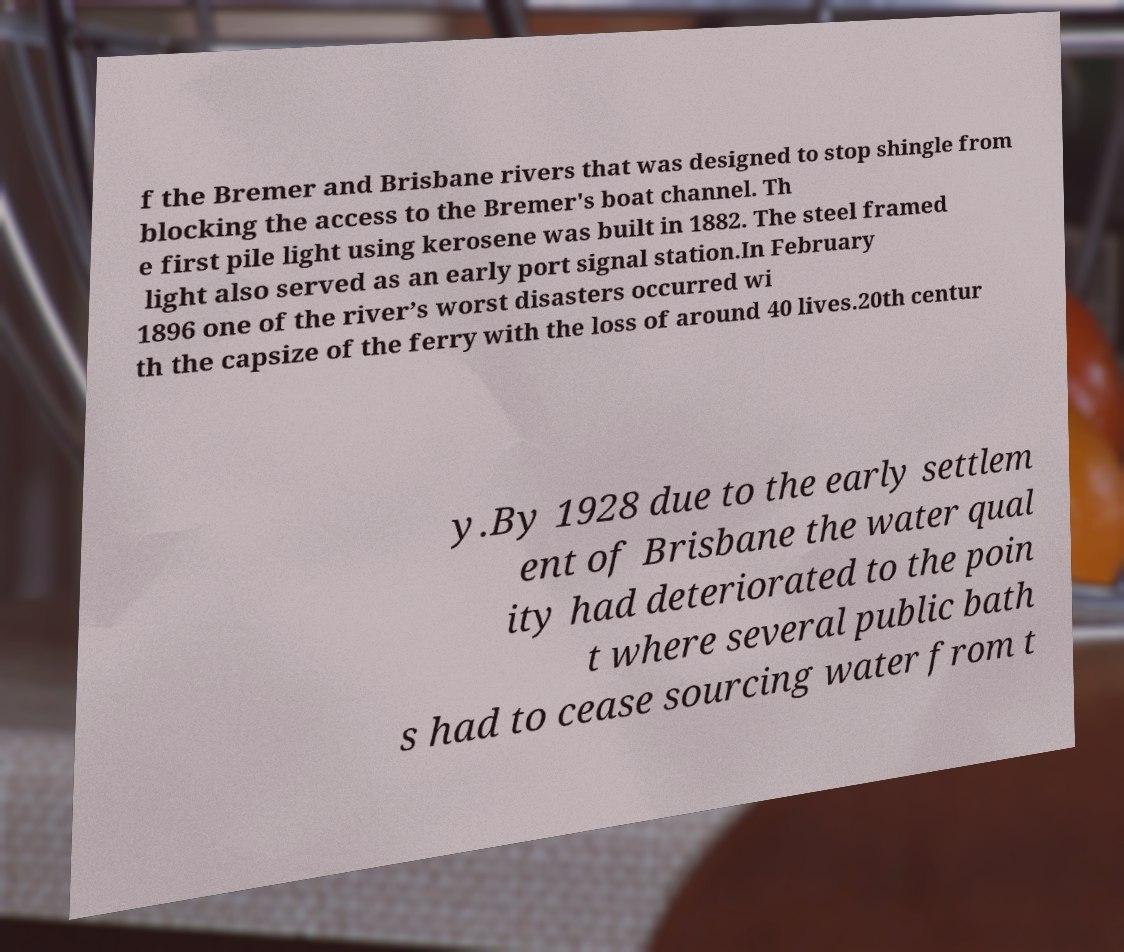Please read and relay the text visible in this image. What does it say? f the Bremer and Brisbane rivers that was designed to stop shingle from blocking the access to the Bremer's boat channel. Th e first pile light using kerosene was built in 1882. The steel framed light also served as an early port signal station.In February 1896 one of the river’s worst disasters occurred wi th the capsize of the ferry with the loss of around 40 lives.20th centur y.By 1928 due to the early settlem ent of Brisbane the water qual ity had deteriorated to the poin t where several public bath s had to cease sourcing water from t 